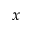Convert formula to latex. <formula><loc_0><loc_0><loc_500><loc_500>x</formula> 